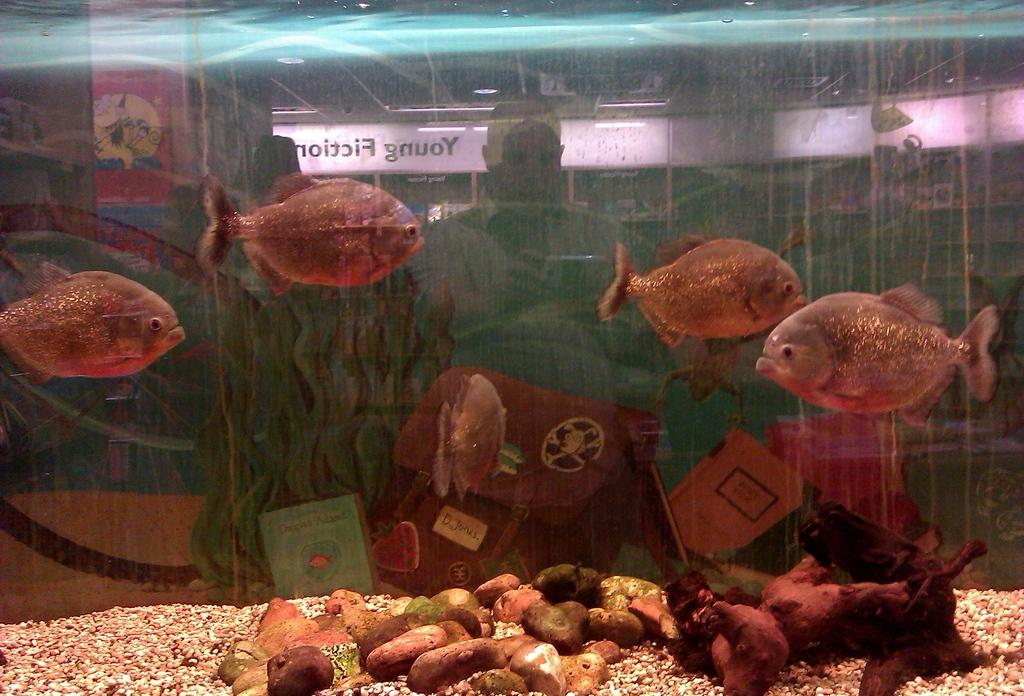What type of environment is depicted in the image? The image appears to be an aquarium. What can be found inside the aquarium? There are fishes and stones in the aquarium. What is the aquarium filled with? There is water in the aquarium. Can you see anything outside the aquarium in the image? Yes, there is a reflection of a man in the glass. Is there any text visible in the image? Yes, there is text on the glass. What type of smell can be detected from the sticks in the image? There are no sticks present in the image, so it is not possible to determine any associated smell. 